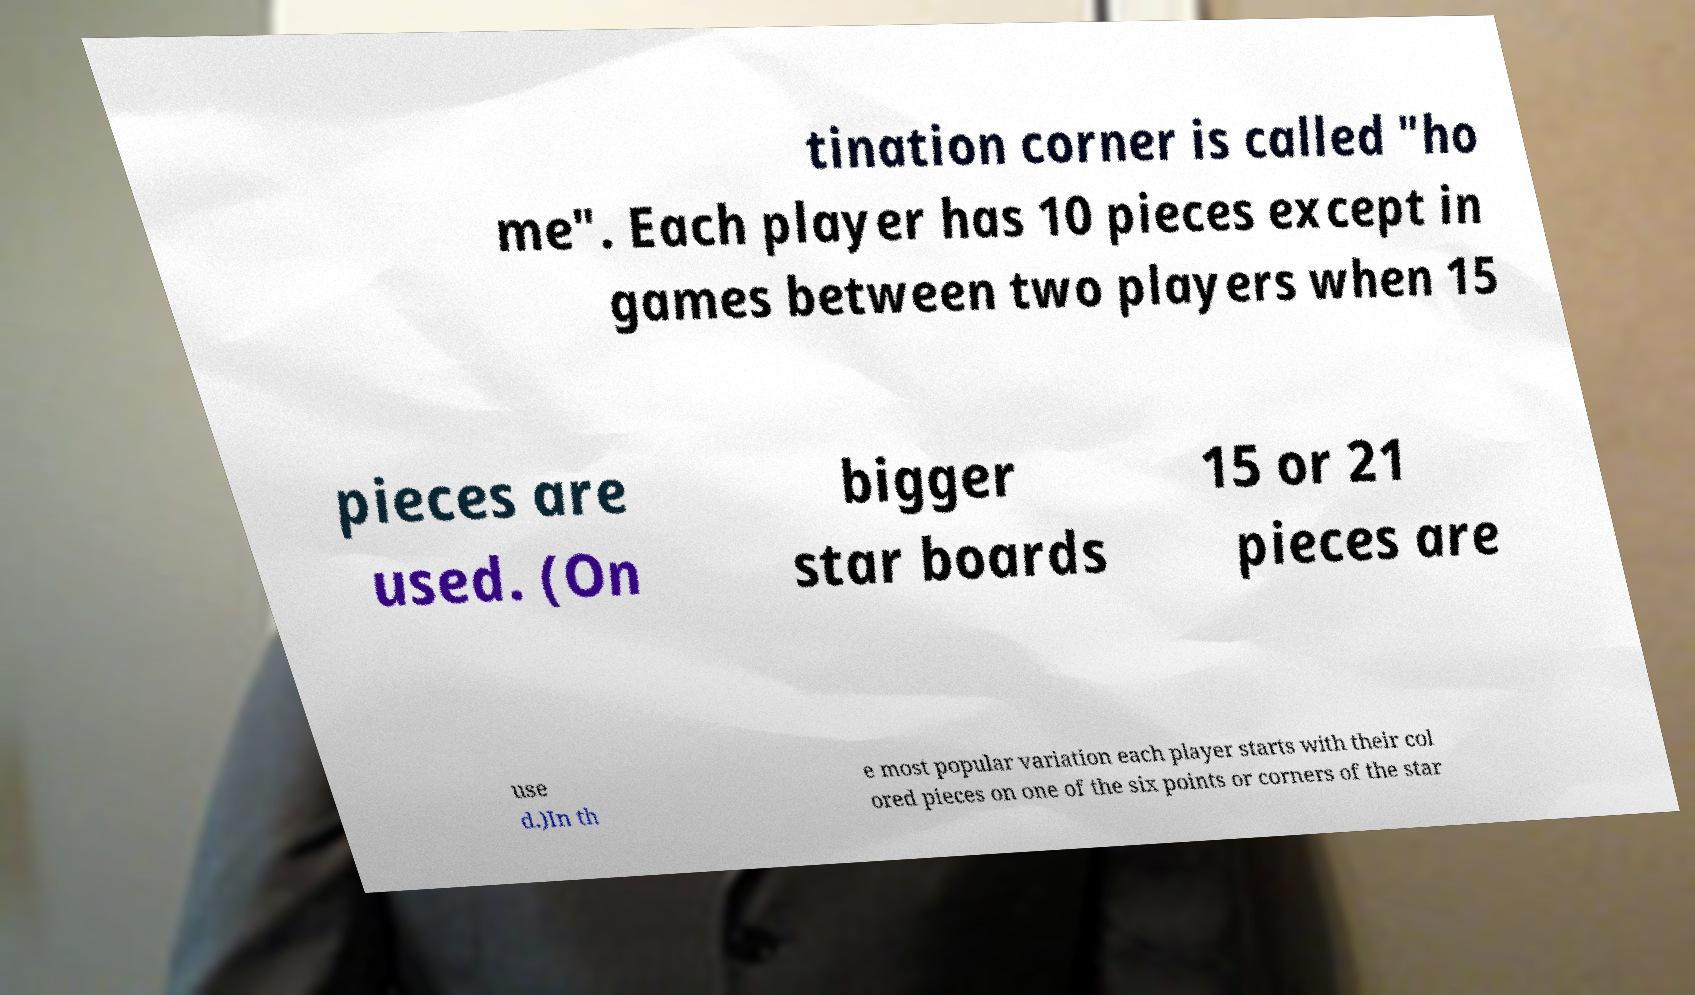Can you read and provide the text displayed in the image?This photo seems to have some interesting text. Can you extract and type it out for me? tination corner is called "ho me". Each player has 10 pieces except in games between two players when 15 pieces are used. (On bigger star boards 15 or 21 pieces are use d.)In th e most popular variation each player starts with their col ored pieces on one of the six points or corners of the star 